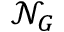Convert formula to latex. <formula><loc_0><loc_0><loc_500><loc_500>\mathcal { N } _ { G }</formula> 